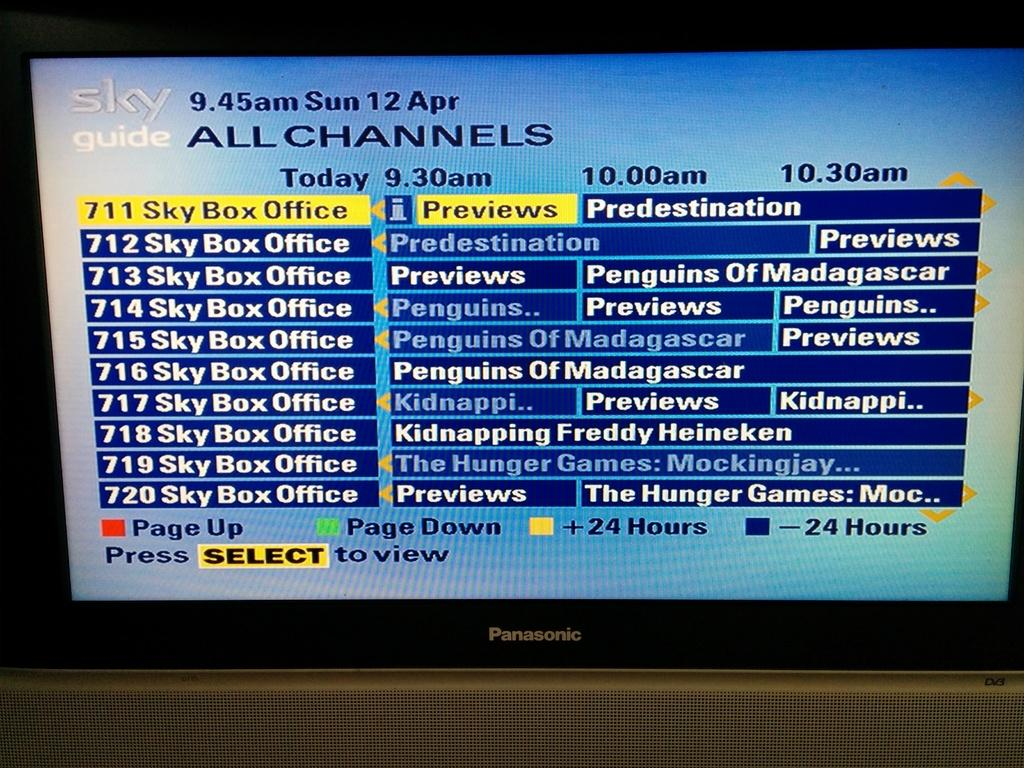<image>
Summarize the visual content of the image. A Sky Guide menu lists a collection of movies like The Hunger Games, Predestination and Penguins of Madagascar. 